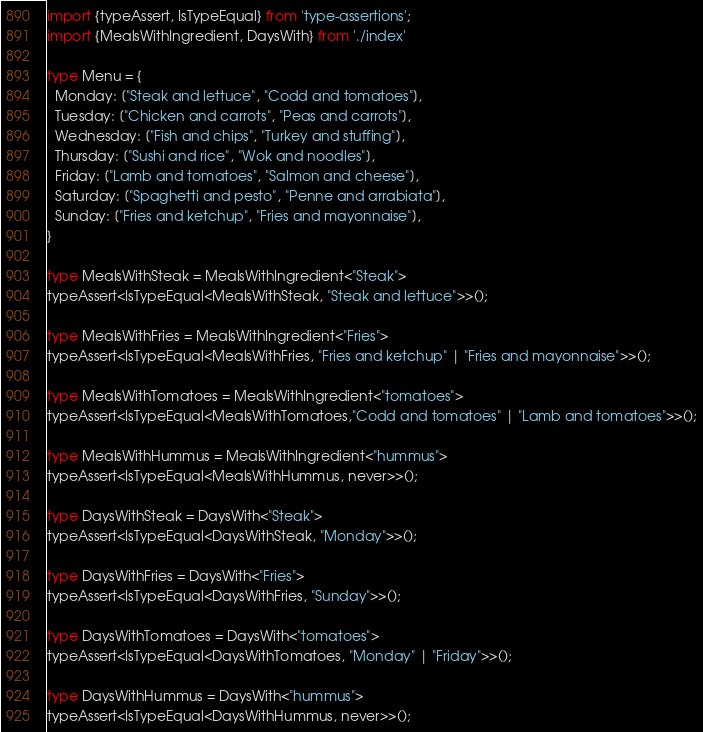<code> <loc_0><loc_0><loc_500><loc_500><_TypeScript_>import {typeAssert, IsTypeEqual} from 'type-assertions';
import {MealsWithIngredient, DaysWith} from './index'

type Menu = {
  Monday: ["Steak and lettuce", "Codd and tomatoes"],
  Tuesday: ["Chicken and carrots", "Peas and carrots"],
  Wednesday: ["Fish and chips", "Turkey and stuffing"],
  Thursday: ["Sushi and rice", "Wok and noodles"],
  Friday: ["Lamb and tomatoes", "Salmon and cheese"],
  Saturday: ["Spaghetti and pesto", "Penne and arrabiata"],
  Sunday: ["Fries and ketchup", "Fries and mayonnaise"],
}

type MealsWithSteak = MealsWithIngredient<"Steak">
typeAssert<IsTypeEqual<MealsWithSteak, "Steak and lettuce">>();

type MealsWithFries = MealsWithIngredient<"Fries">
typeAssert<IsTypeEqual<MealsWithFries, "Fries and ketchup" | "Fries and mayonnaise">>();

type MealsWithTomatoes = MealsWithIngredient<"tomatoes">
typeAssert<IsTypeEqual<MealsWithTomatoes,"Codd and tomatoes" | "Lamb and tomatoes">>();

type MealsWithHummus = MealsWithIngredient<"hummus">
typeAssert<IsTypeEqual<MealsWithHummus, never>>();

type DaysWithSteak = DaysWith<"Steak">
typeAssert<IsTypeEqual<DaysWithSteak, "Monday">>();

type DaysWithFries = DaysWith<"Fries">
typeAssert<IsTypeEqual<DaysWithFries, "Sunday">>();

type DaysWithTomatoes = DaysWith<"tomatoes">
typeAssert<IsTypeEqual<DaysWithTomatoes, "Monday" | "Friday">>();

type DaysWithHummus = DaysWith<"hummus">
typeAssert<IsTypeEqual<DaysWithHummus, never>>();
</code> 